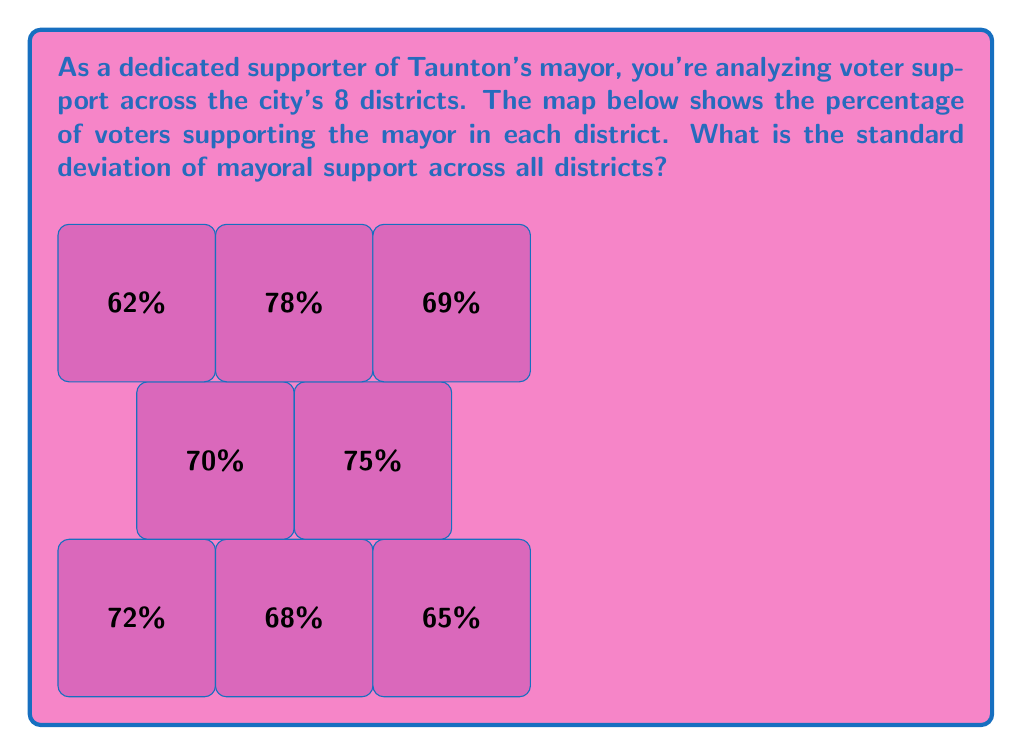Give your solution to this math problem. Let's approach this step-by-step:

1) First, we need to calculate the mean percentage of support across all districts.

   Mean = $\frac{72 + 68 + 65 + 70 + 75 + 62 + 78 + 69}{8} = \frac{559}{8} = 69.875\%$

2) Now, we calculate the squared differences from the mean:

   $(72 - 69.875)^2 = 4.515625$
   $(68 - 69.875)^2 = 3.515625$
   $(65 - 69.875)^2 = 23.765625$
   $(70 - 69.875)^2 = 0.015625$
   $(75 - 69.875)^2 = 26.265625$
   $(62 - 69.875)^2 = 61.765625$
   $(78 - 69.875)^2 = 66.015625$
   $(69 - 69.875)^2 = 0.765625$

3) Sum these squared differences:

   $4.515625 + 3.515625 + 23.765625 + 0.015625 + 26.265625 + 61.765625 + 66.015625 + 0.765625 = 186.625$

4) Divide by the number of districts (8):

   $\frac{186.625}{8} = 23.328125$

5) Take the square root to get the standard deviation:

   $\sqrt{23.328125} = 4.83$

Therefore, the standard deviation of mayoral support across all districts is approximately 4.83%.
Answer: $4.83\%$ 